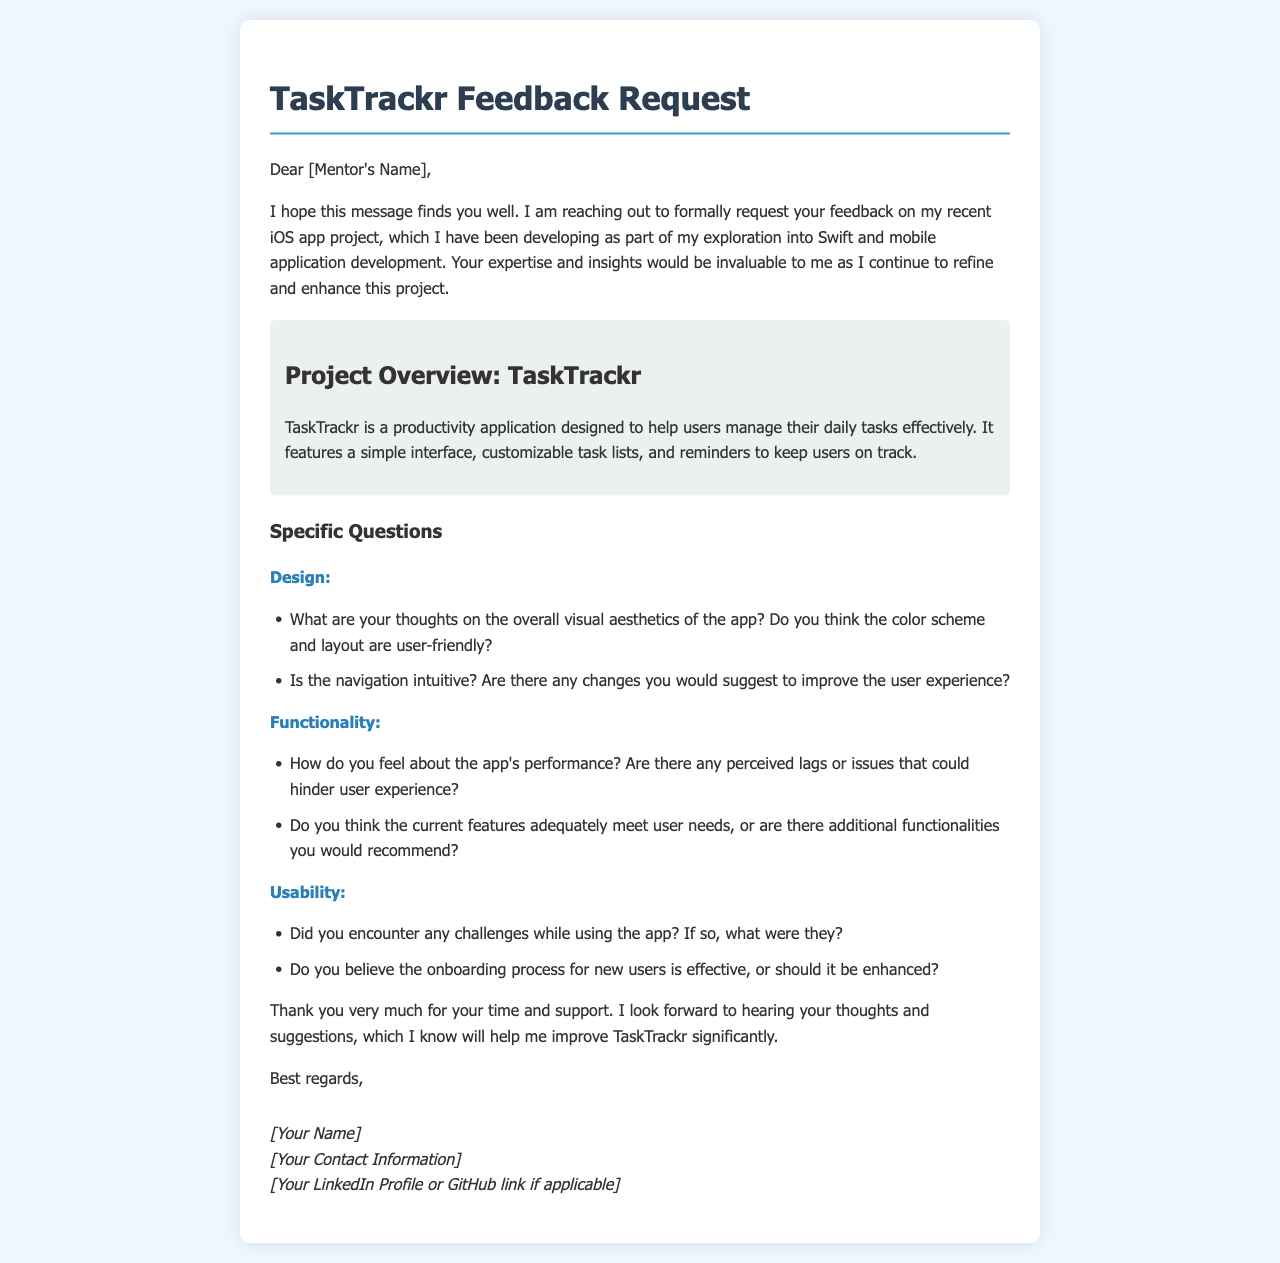What is the name of the app project? The name of the app project is mentioned in the project overview section of the document.
Answer: TaskTrackr Who is the feedback requested from? The document addresses the feedback request to the mentor, as indicated at the beginning.
Answer: [Mentor's Name] What are the main features of the app? The main features are listed in the project overview section of the letter and describe what the app does.
Answer: Customizable task lists and reminders What is the preferred contact information format requested in the letter? The letter asks for specific contact information to be included in the signature section.
Answer: [Your Contact Information] What is the purpose of the app as described in the document? The purpose is clarified in the project overview, outlining the main goal of the app.
Answer: Help users manage their daily tasks What are two major categories of questions included in the feedback request? The document organizes the questions into specific categories for clarity.
Answer: Design and Functionality Did the author mention any performance concerns about the app? The author specifically asks for feedback about performance in the functionality section.
Answer: Yes What is the visual theme of the document? The overall color scheme and visuals expressed are stated implicitly in the design description within the document.
Answer: Blue and white What does the author hope to achieve with the feedback? The goal of the feedback is summarized towards the end of the document, indicating the author's intention.
Answer: Improve TaskTrackr significantly 